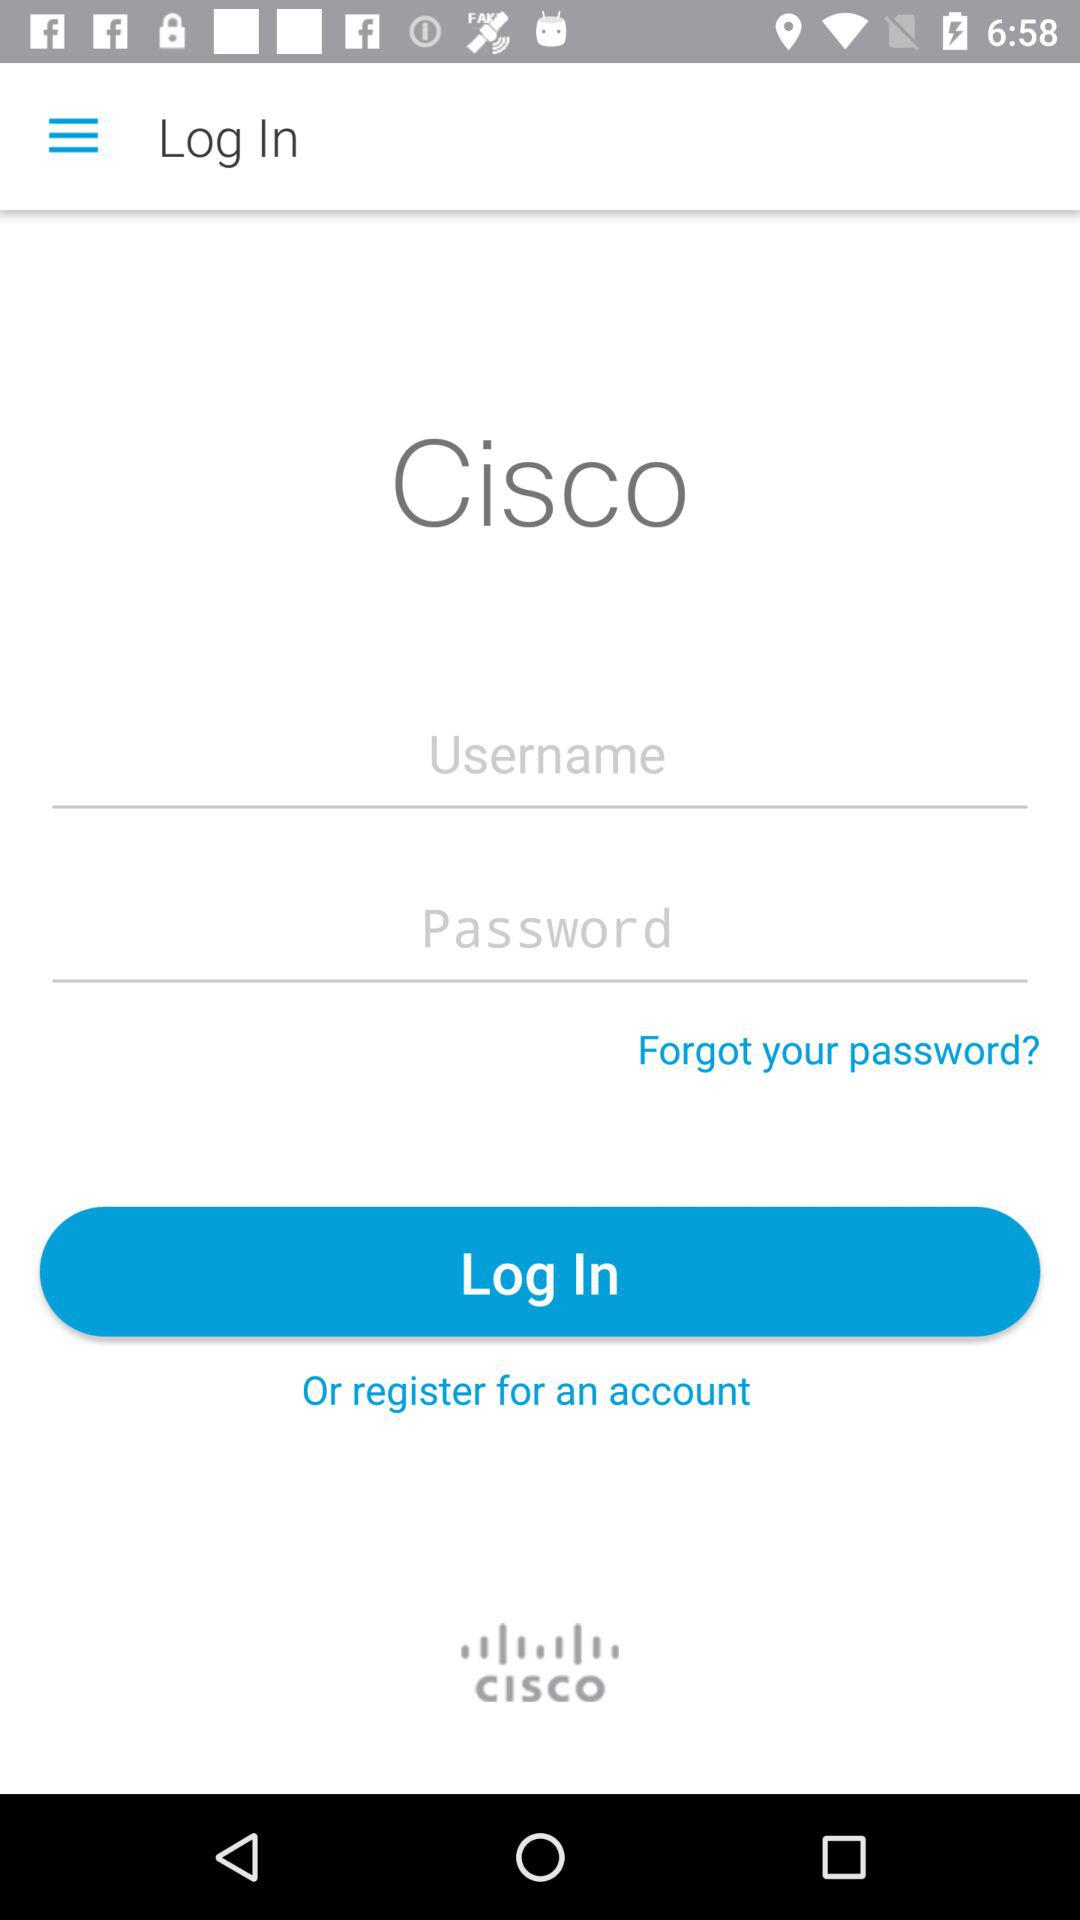How many characters are required to create a password?
When the provided information is insufficient, respond with <no answer>. <no answer> 